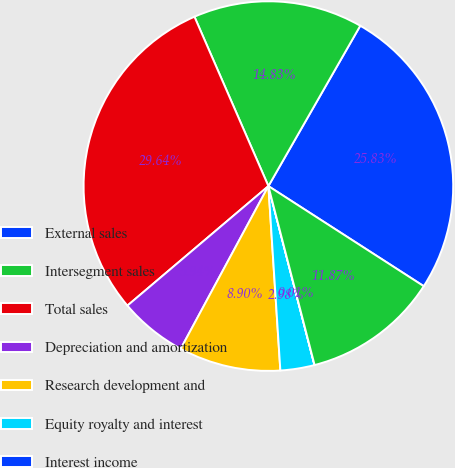Convert chart. <chart><loc_0><loc_0><loc_500><loc_500><pie_chart><fcel>External sales<fcel>Intersegment sales<fcel>Total sales<fcel>Depreciation and amortization<fcel>Research development and<fcel>Equity royalty and interest<fcel>Interest income<fcel>Segment EBIT<nl><fcel>25.83%<fcel>14.83%<fcel>29.64%<fcel>5.94%<fcel>8.9%<fcel>2.98%<fcel>0.01%<fcel>11.87%<nl></chart> 